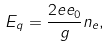<formula> <loc_0><loc_0><loc_500><loc_500>E _ { q } = \frac { 2 e e _ { 0 } } { g } n _ { e } ,</formula> 